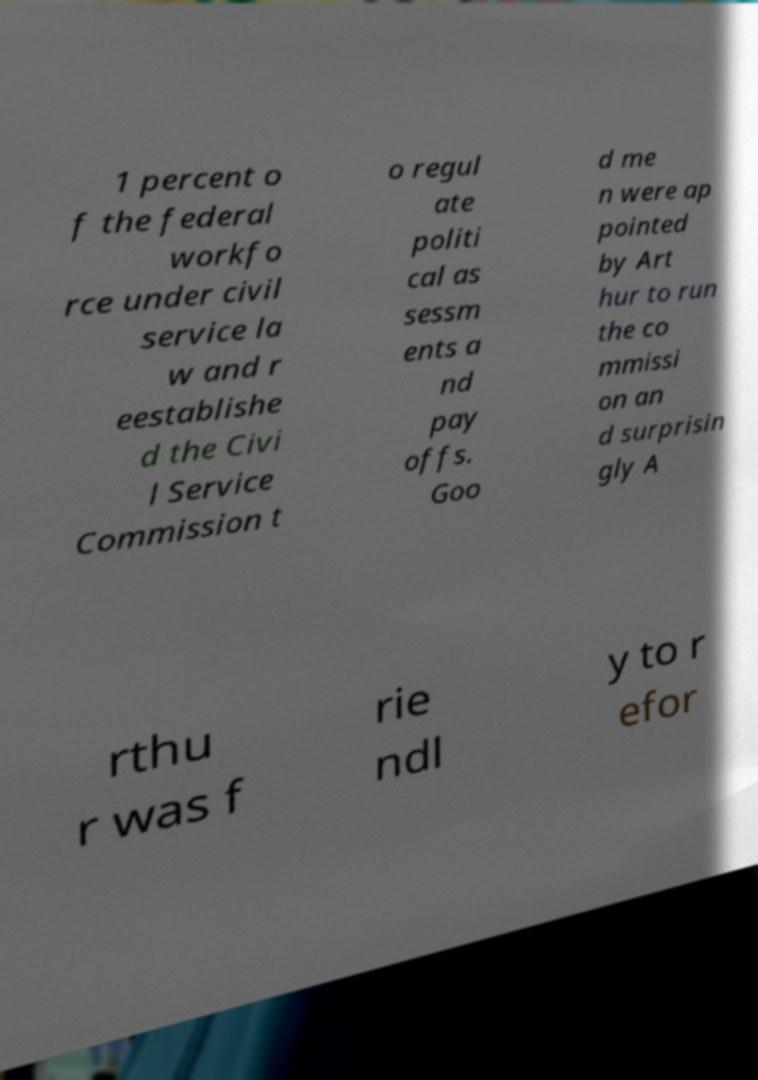What messages or text are displayed in this image? I need them in a readable, typed format. 1 percent o f the federal workfo rce under civil service la w and r eestablishe d the Civi l Service Commission t o regul ate politi cal as sessm ents a nd pay offs. Goo d me n were ap pointed by Art hur to run the co mmissi on an d surprisin gly A rthu r was f rie ndl y to r efor 